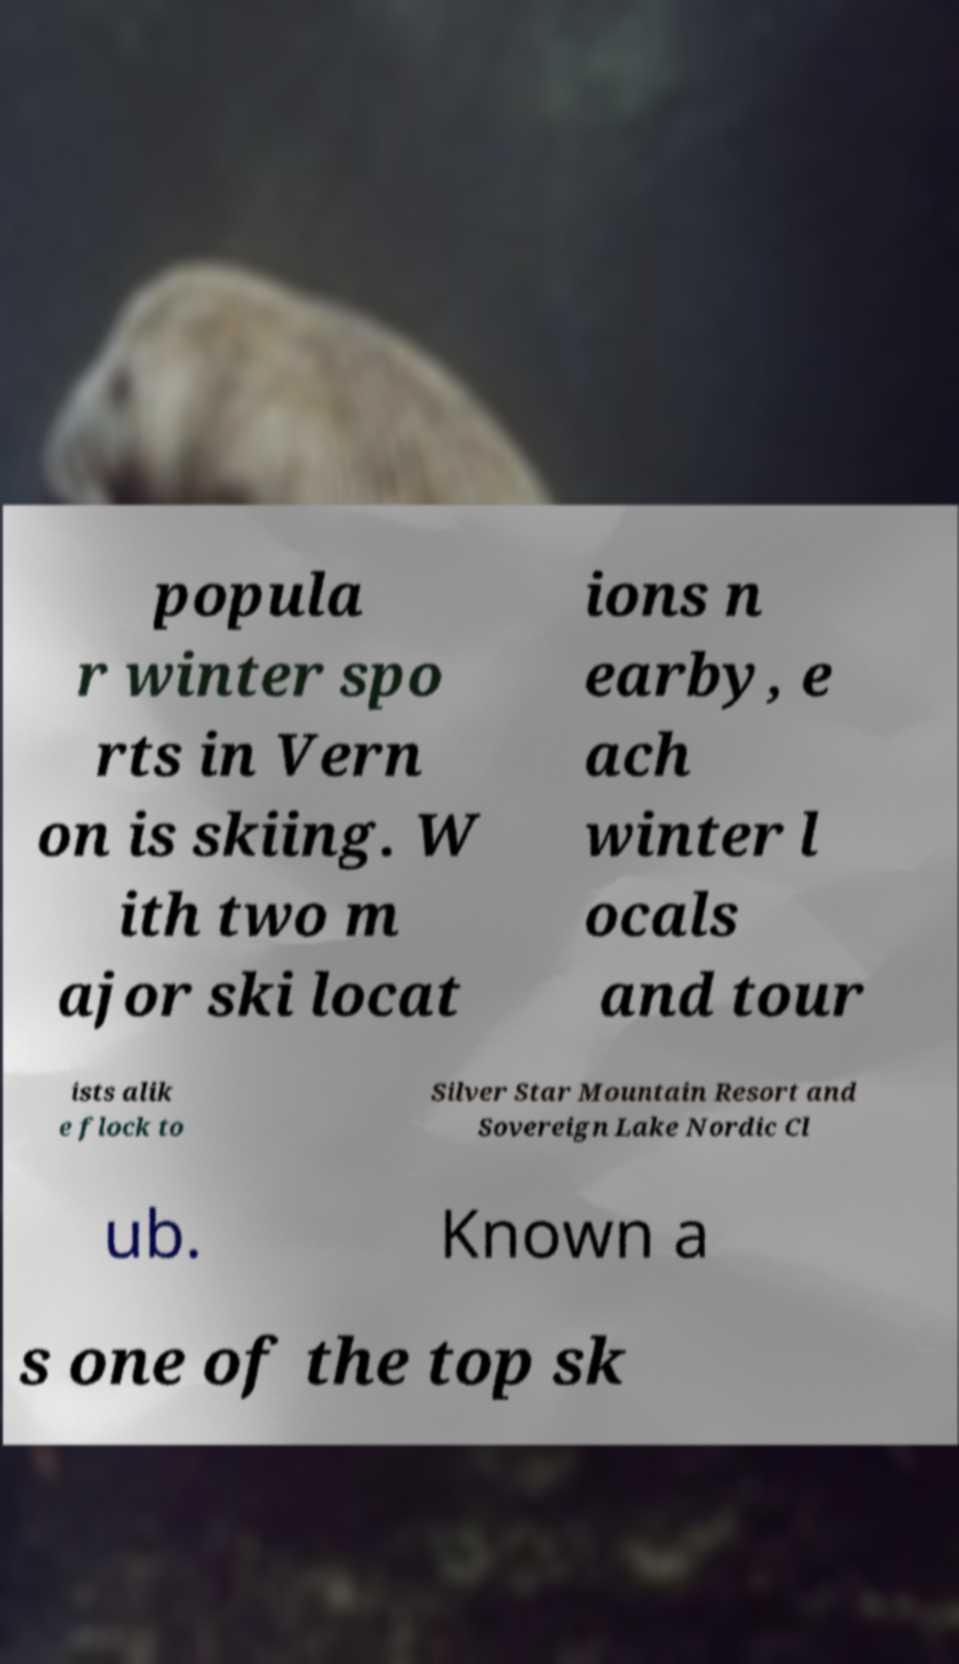I need the written content from this picture converted into text. Can you do that? popula r winter spo rts in Vern on is skiing. W ith two m ajor ski locat ions n earby, e ach winter l ocals and tour ists alik e flock to Silver Star Mountain Resort and Sovereign Lake Nordic Cl ub. Known a s one of the top sk 